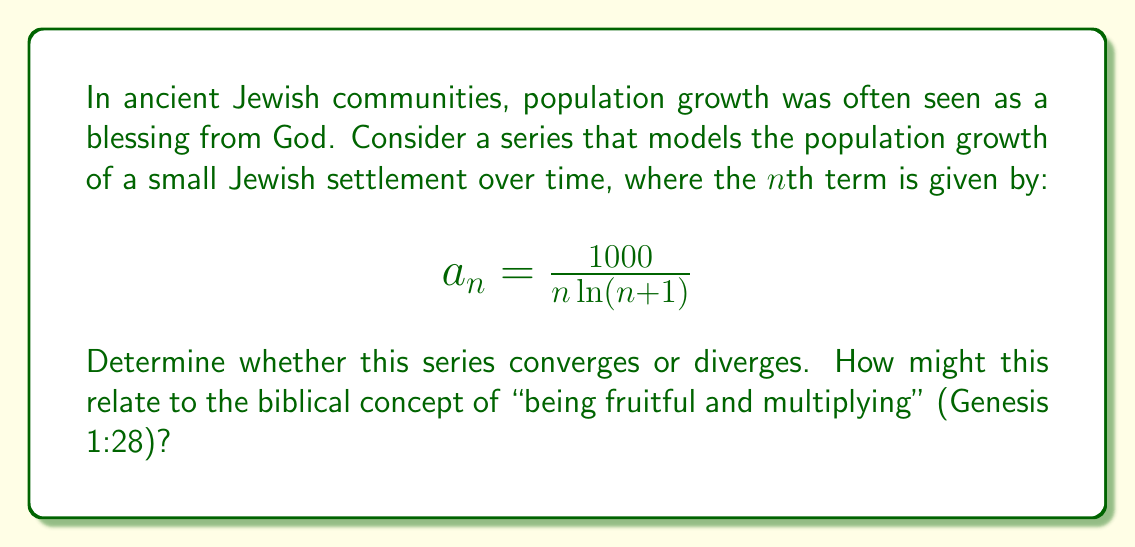Could you help me with this problem? To determine the convergence of this series, we can use the integral test. Let's approach this step-by-step:

1) First, we need to check if the function $f(x) = \frac{1000}{x \ln(x+1)}$ is continuous, positive, and decreasing for $x \geq 1$. It clearly satisfies these conditions.

2) Now, we can apply the integral test. We need to evaluate the improper integral:

   $$\int_1^{\infty} \frac{1000}{x \ln(x+1)} dx$$

3) Let's make a substitution: $u = \ln(x+1)$, so $du = \frac{1}{x+1}dx$ or $dx = (x+1)du$

4) When $x = 1$, $u = \ln(2)$, and as $x \to \infty$, $u \to \infty$

5) Substituting:

   $$\int_{\ln(2)}^{\infty} \frac{1000}{(e^u - 1)u} \cdot e^u du = 1000 \int_{\ln(2)}^{\infty} \frac{1}{u(e^u - 1)} \cdot e^u du$$

6) As $u \to \infty$, $\frac{e^u}{e^u - 1} \to 1$, so for large $u$, our integral behaves like:

   $$1000 \int_{\ln(2)}^{\infty} \frac{1}{u} du$$

7) This is a well-known divergent integral (it's the natural log function, which grows without bound).

Therefore, by the integral test, our original series diverges.

From a spiritual perspective, this divergence could be seen as reflecting the biblical mandate to "be fruitful and multiply." The divergence suggests unbounded growth, aligning with the idea of continual expansion of the Jewish people. However, it's important to note that real-world population growth is more complex and eventually limited by resources.
Answer: The series diverges. 